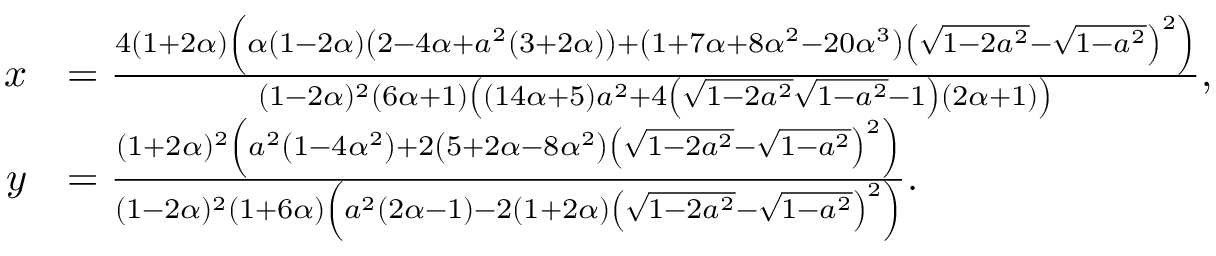<formula> <loc_0><loc_0><loc_500><loc_500>\begin{array} { r l } { x } & { = \frac { 4 ( 1 + 2 \alpha ) \left ( \alpha ( 1 - 2 \alpha ) \left ( 2 - 4 \alpha + a ^ { 2 } ( 3 + 2 \alpha ) \right ) + \left ( 1 + 7 \alpha + 8 \alpha ^ { 2 } - 2 0 \alpha ^ { 3 } \right ) \left ( \sqrt { 1 - 2 a ^ { 2 } } - \sqrt { 1 - a ^ { 2 } } \right ) ^ { 2 } \right ) } { ( 1 - 2 \alpha ) ^ { 2 } ( 6 \alpha + 1 ) \left ( ( 1 4 \alpha + 5 ) a ^ { 2 } + 4 \left ( \sqrt { 1 - 2 a ^ { 2 } } \sqrt { 1 - a ^ { 2 } } - 1 \right ) ( 2 \alpha + 1 ) \right ) } , } \\ { y } & { = \frac { ( 1 + 2 \alpha ) ^ { 2 } \left ( a ^ { 2 } \left ( 1 - 4 \alpha ^ { 2 } \right ) + 2 \left ( 5 + 2 \alpha - 8 \alpha ^ { 2 } \right ) \left ( \sqrt { 1 - 2 a ^ { 2 } } - \sqrt { 1 - a ^ { 2 } } \right ) ^ { 2 } \right ) } { ( 1 - 2 \alpha ) ^ { 2 } ( 1 + 6 \alpha ) \left ( a ^ { 2 } ( 2 \alpha - 1 ) - 2 ( 1 + 2 \alpha ) \left ( \sqrt { 1 - 2 a ^ { 2 } } - \sqrt { 1 - a ^ { 2 } } \right ) ^ { 2 } \right ) } . } \end{array}</formula> 